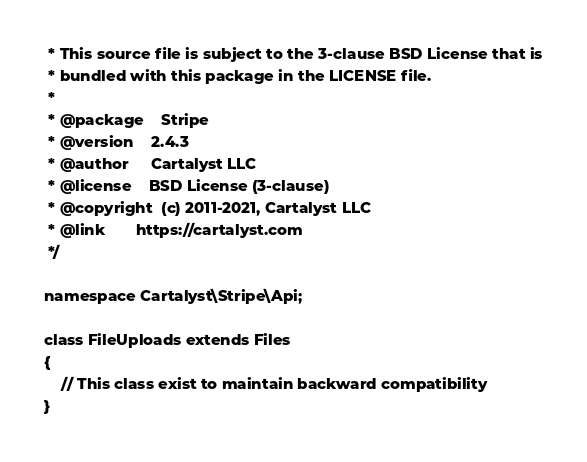Convert code to text. <code><loc_0><loc_0><loc_500><loc_500><_PHP_> * This source file is subject to the 3-clause BSD License that is
 * bundled with this package in the LICENSE file.
 *
 * @package    Stripe
 * @version    2.4.3
 * @author     Cartalyst LLC
 * @license    BSD License (3-clause)
 * @copyright  (c) 2011-2021, Cartalyst LLC
 * @link       https://cartalyst.com
 */

namespace Cartalyst\Stripe\Api;

class FileUploads extends Files
{
    // This class exist to maintain backward compatibility
}
</code> 